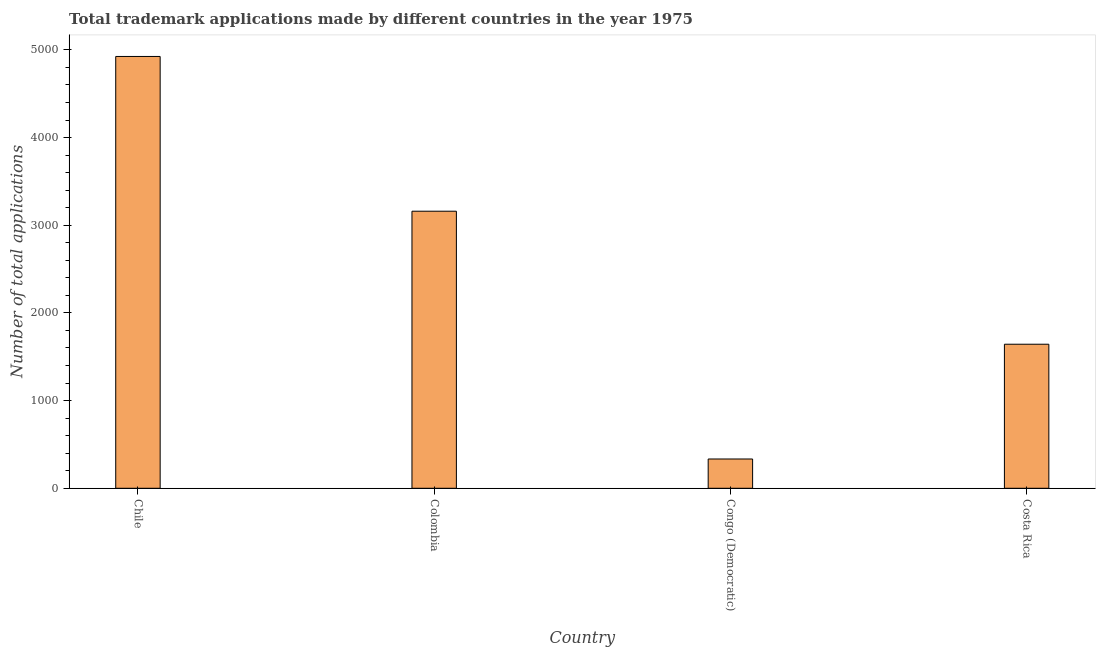Does the graph contain grids?
Your answer should be compact. No. What is the title of the graph?
Your answer should be compact. Total trademark applications made by different countries in the year 1975. What is the label or title of the Y-axis?
Your answer should be very brief. Number of total applications. What is the number of trademark applications in Colombia?
Make the answer very short. 3160. Across all countries, what is the maximum number of trademark applications?
Your answer should be compact. 4925. Across all countries, what is the minimum number of trademark applications?
Provide a short and direct response. 334. In which country was the number of trademark applications minimum?
Your answer should be compact. Congo (Democratic). What is the sum of the number of trademark applications?
Provide a succinct answer. 1.01e+04. What is the difference between the number of trademark applications in Colombia and Congo (Democratic)?
Ensure brevity in your answer.  2826. What is the average number of trademark applications per country?
Offer a terse response. 2515. What is the median number of trademark applications?
Offer a very short reply. 2401.5. In how many countries, is the number of trademark applications greater than 4600 ?
Provide a short and direct response. 1. What is the ratio of the number of trademark applications in Congo (Democratic) to that in Costa Rica?
Offer a terse response. 0.2. Is the number of trademark applications in Chile less than that in Colombia?
Keep it short and to the point. No. Is the difference between the number of trademark applications in Chile and Colombia greater than the difference between any two countries?
Ensure brevity in your answer.  No. What is the difference between the highest and the second highest number of trademark applications?
Make the answer very short. 1765. What is the difference between the highest and the lowest number of trademark applications?
Give a very brief answer. 4591. How many bars are there?
Give a very brief answer. 4. Are all the bars in the graph horizontal?
Offer a very short reply. No. How many countries are there in the graph?
Your answer should be very brief. 4. What is the Number of total applications of Chile?
Provide a succinct answer. 4925. What is the Number of total applications in Colombia?
Give a very brief answer. 3160. What is the Number of total applications in Congo (Democratic)?
Ensure brevity in your answer.  334. What is the Number of total applications in Costa Rica?
Your response must be concise. 1643. What is the difference between the Number of total applications in Chile and Colombia?
Your answer should be very brief. 1765. What is the difference between the Number of total applications in Chile and Congo (Democratic)?
Your answer should be compact. 4591. What is the difference between the Number of total applications in Chile and Costa Rica?
Provide a short and direct response. 3282. What is the difference between the Number of total applications in Colombia and Congo (Democratic)?
Make the answer very short. 2826. What is the difference between the Number of total applications in Colombia and Costa Rica?
Ensure brevity in your answer.  1517. What is the difference between the Number of total applications in Congo (Democratic) and Costa Rica?
Your answer should be compact. -1309. What is the ratio of the Number of total applications in Chile to that in Colombia?
Provide a succinct answer. 1.56. What is the ratio of the Number of total applications in Chile to that in Congo (Democratic)?
Your answer should be very brief. 14.75. What is the ratio of the Number of total applications in Chile to that in Costa Rica?
Make the answer very short. 3. What is the ratio of the Number of total applications in Colombia to that in Congo (Democratic)?
Make the answer very short. 9.46. What is the ratio of the Number of total applications in Colombia to that in Costa Rica?
Keep it short and to the point. 1.92. What is the ratio of the Number of total applications in Congo (Democratic) to that in Costa Rica?
Provide a succinct answer. 0.2. 